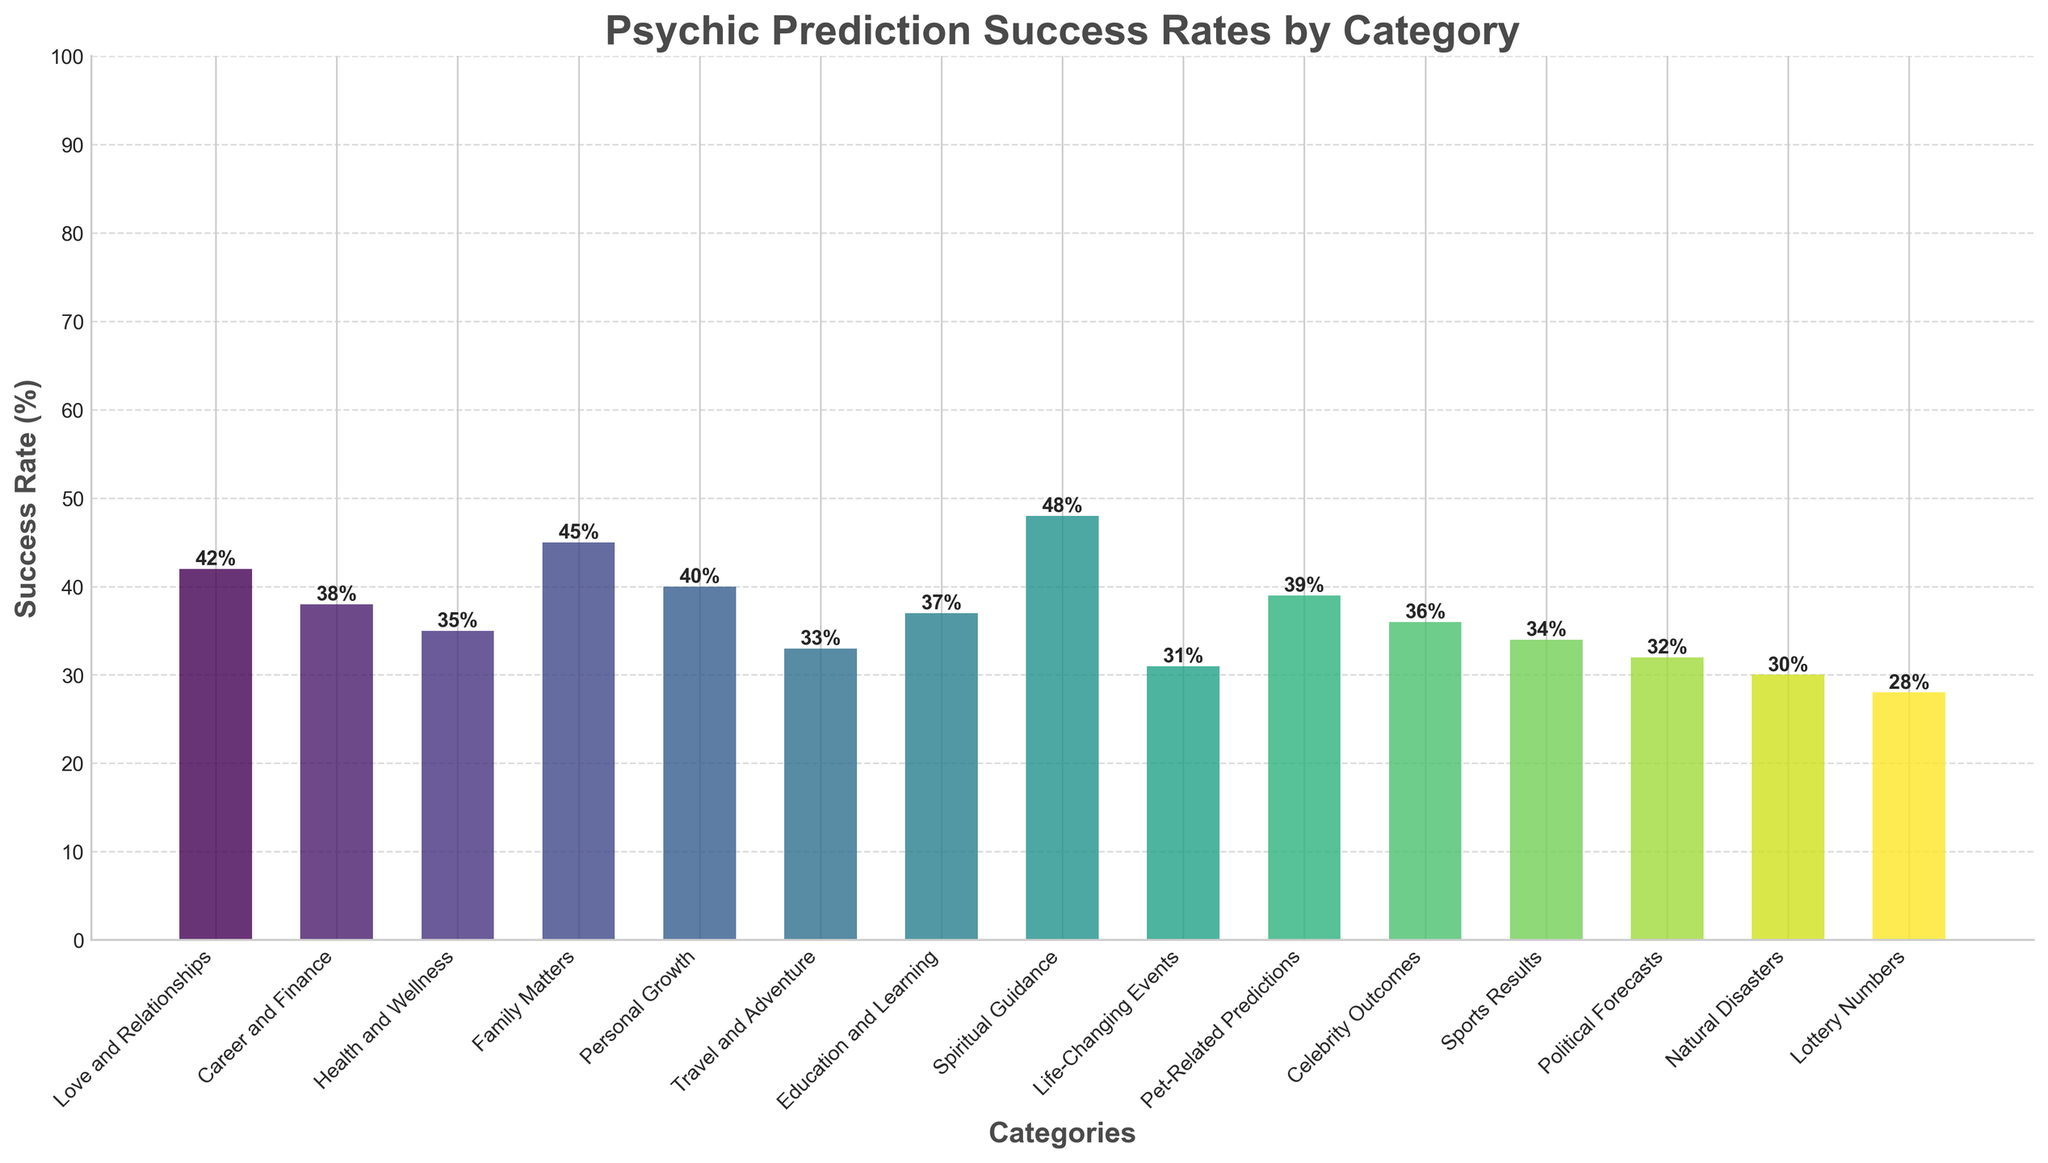Which category has the highest psychic prediction success rate? The highest bar in the chart represents "Spiritual Guidance" with a success rate of 48%. Therefore, it has the highest psychic prediction success rate.
Answer: Spiritual Guidance Which category has the lowest psychic prediction success rate? The lowest bar in the chart represents "Lottery Numbers" with a success rate of 28%. Therefore, it has the lowest psychic prediction success rate.
Answer: Lottery Numbers What is the average success rate across all categories? Summing up all success rates: (42+38+35+45+40+33+37+48+31+39+36+34+32+30+28) = 548. There are 15 categories, so the average success rate is 548/15 = 36.53%.
Answer: 36.53% Which categories have a success rate higher than 40%? The bars with success rates higher than 40% represent the categories "Love and Relationships," "Family Matters," and "Spiritual Guidance," which have success rates of 42%, 45%, and 48%, respectively.
Answer: Love and Relationships, Family Matters, Spiritual Guidance What's the difference between the highest and the lowest success rate? The highest success rate is 48% (Spiritual Guidance) and the lowest is 28% (Lottery Numbers), so the difference is 48% - 28% = 20%.
Answer: 20% What is the success rate of predictions related to health and wellness? The bar representing "Health and Wellness" shows a success rate of 35%. Therefore, the success rate for health-related predictions is 35%.
Answer: 35% Which category has a similar success rate to 'Education and Learning'? The success rate for "Education and Learning" is 37%. The category "Career and Finance" has a success rate of 38%, which is the closest to 37%.
Answer: Career and Finance How many categories have a success rate between 30% and 40%? The bars for "Health and Wellness" (35%), "Travel and Adventure" (33%), "Education and Learning" (37%), "Celebrity Outcomes" (36%), "Sports Results" (34%), "Political Forecasts" (32%), and "Pet-Related Predictions" (39%) fall between 30% and 40%, giving a total of 7 categories.
Answer: 7 What's the combined success rate of 'Family Matters' and 'Career and Finance'? The success rates are 45% (Family Matters) and 38% (Career and Finance), so their combined success rate is 45% + 38% = 83%.
Answer: 83% How much higher is the success rate of 'Spiritual Guidance' compared to 'Natural Disasters'? The success rates are 48% (Spiritual Guidance) and 30% (Natural Disasters). The difference is 48% - 30% = 18%.
Answer: 18% 